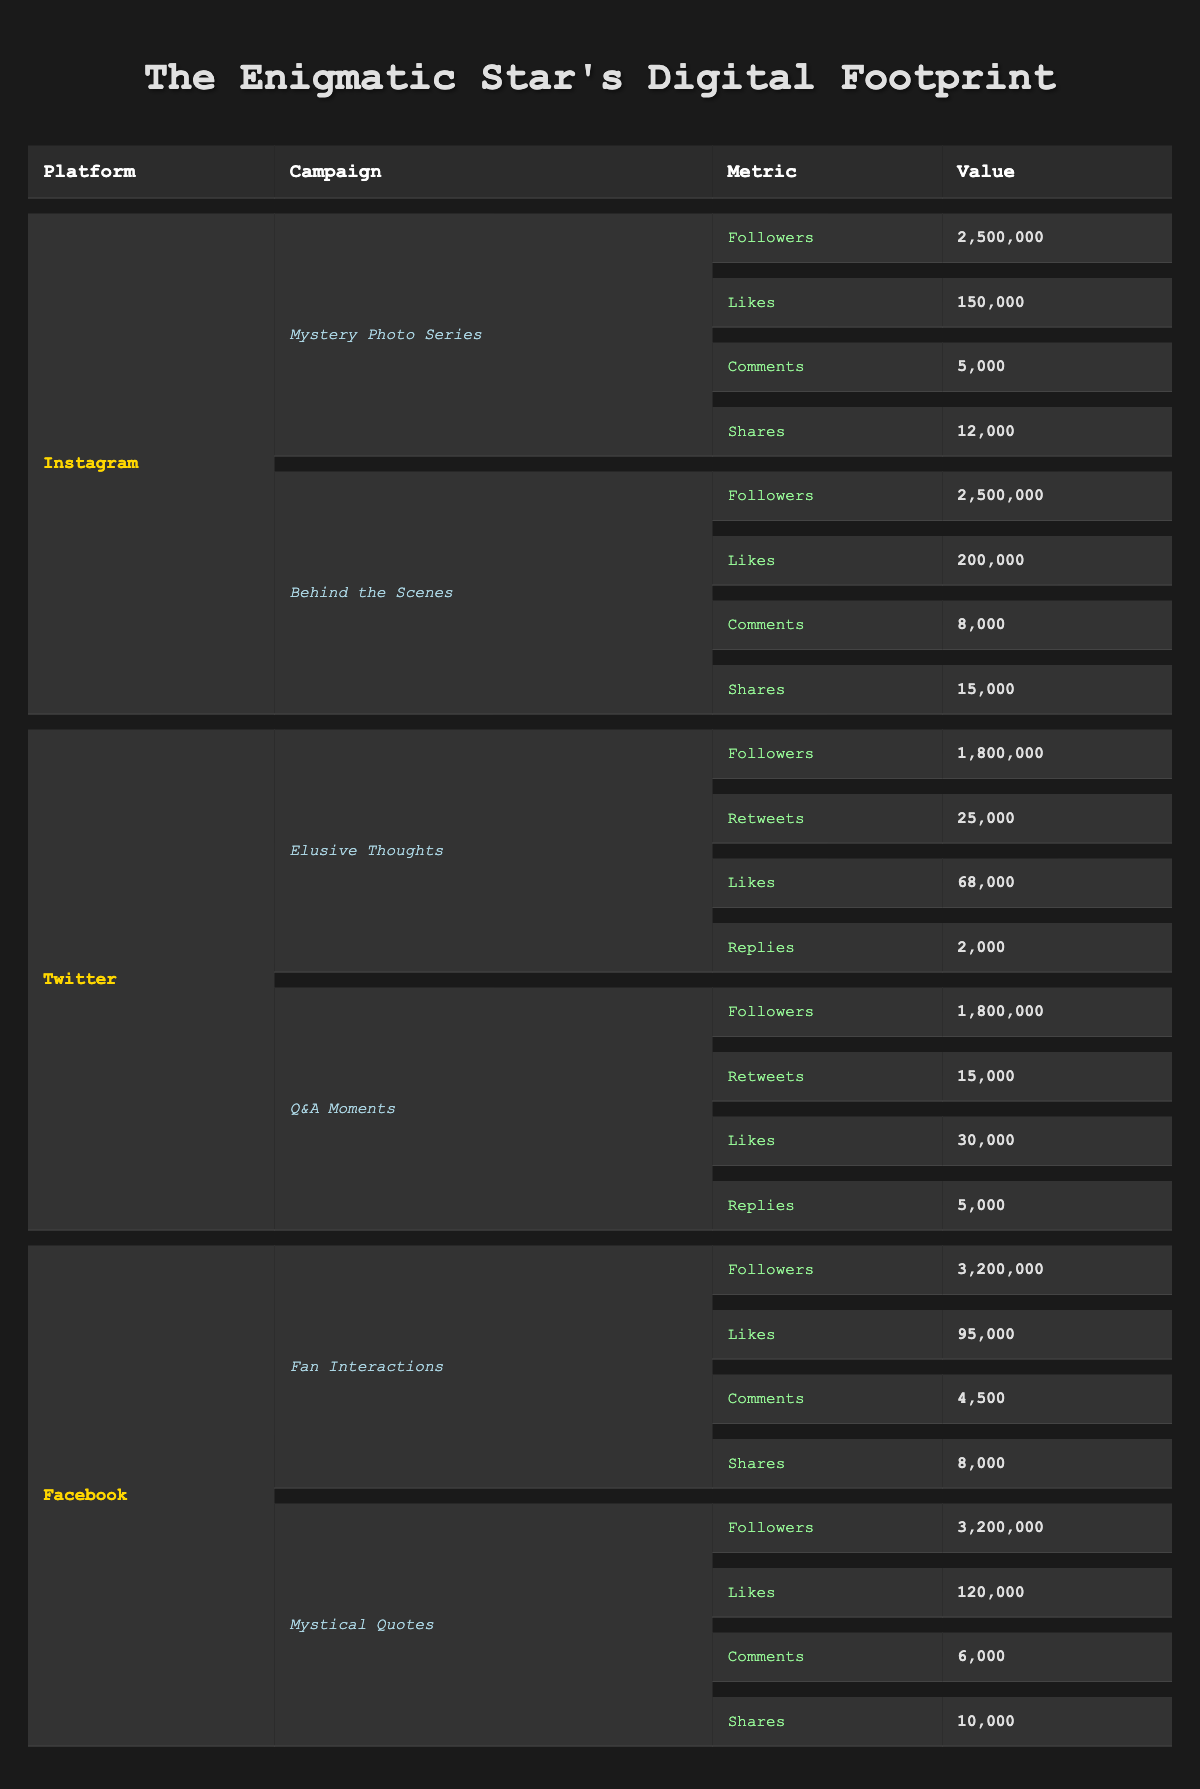What are the total shares from the "Behind the Scenes" campaign on Instagram? The value of shares for the "Behind the Scenes" campaign on Instagram is 15,000. I only need to refer to the specific row for that campaign in the table.
Answer: 15,000 Which platform had the most followers across all campaigns listed? The highest follower count is found on Facebook with 3,200,000 followers, compared to Instagram and Twitter, which have lower counts (2,500,000 and 1,800,000 respectively).
Answer: Facebook How many total likes did the "Elusive Thoughts" and "Q&A Moments" campaigns on Twitter receive combined? The likes for "Elusive Thoughts" are 68,000 and for "Q&A Moments" are 30,000. Adding these together gives 68,000 + 30,000 = 98,000.
Answer: 98,000 Did the "Mystery Photo Series" campaign on Instagram receive more likes than the "Fan Interactions" campaign on Facebook? The "Mystery Photo Series" has 150,000 likes while the "Fan Interactions" campaign has 95,000 likes. Since 150,000 is greater than 95,000, the statement is true.
Answer: Yes What is the overall average number of comments across all campaigns? The total comments from all campaigns are 5,000 + 8,000 + 4,500 + 6,000 (from Instagram, Twitter, and Facebook), totaling 23,500. With 8 campaigns, the average is 23,500 / 8 = 2,937.5.
Answer: 2,937.5 